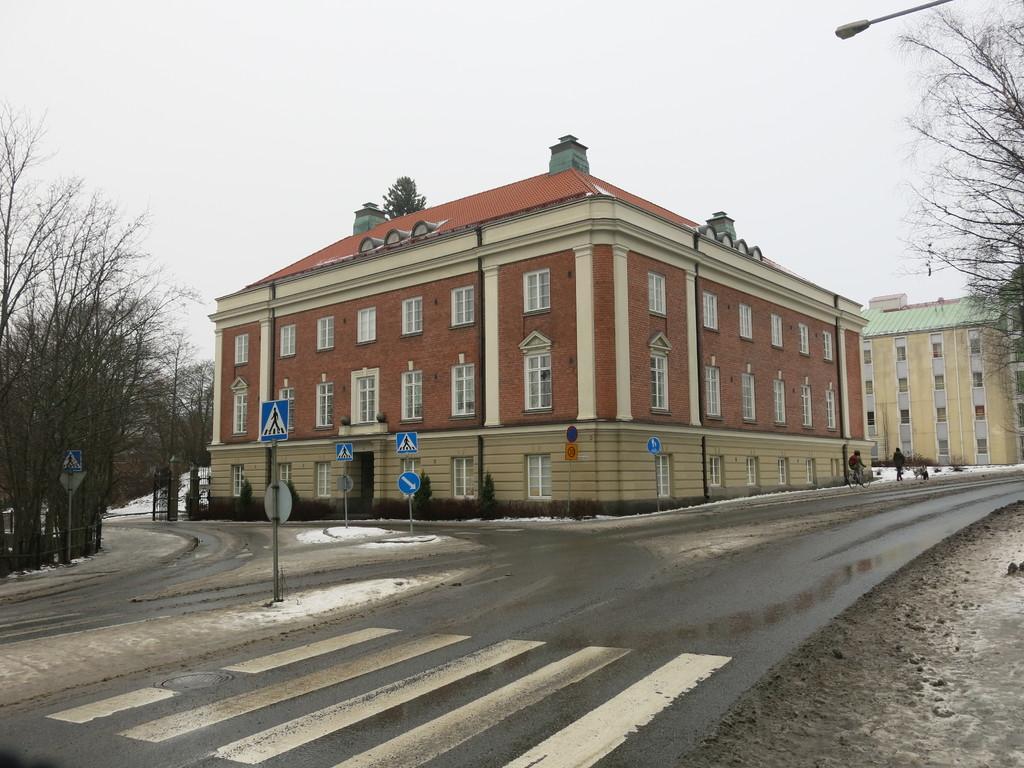In one or two sentences, can you explain what this image depicts? In this picture we can see the buildings, windows, door, bushes, poles, sign boards. In the background of the image we can see the trees and the road. On the right side of the image we can see the light and two people are riding their bicycles. At the top of the image we can see the sky. 